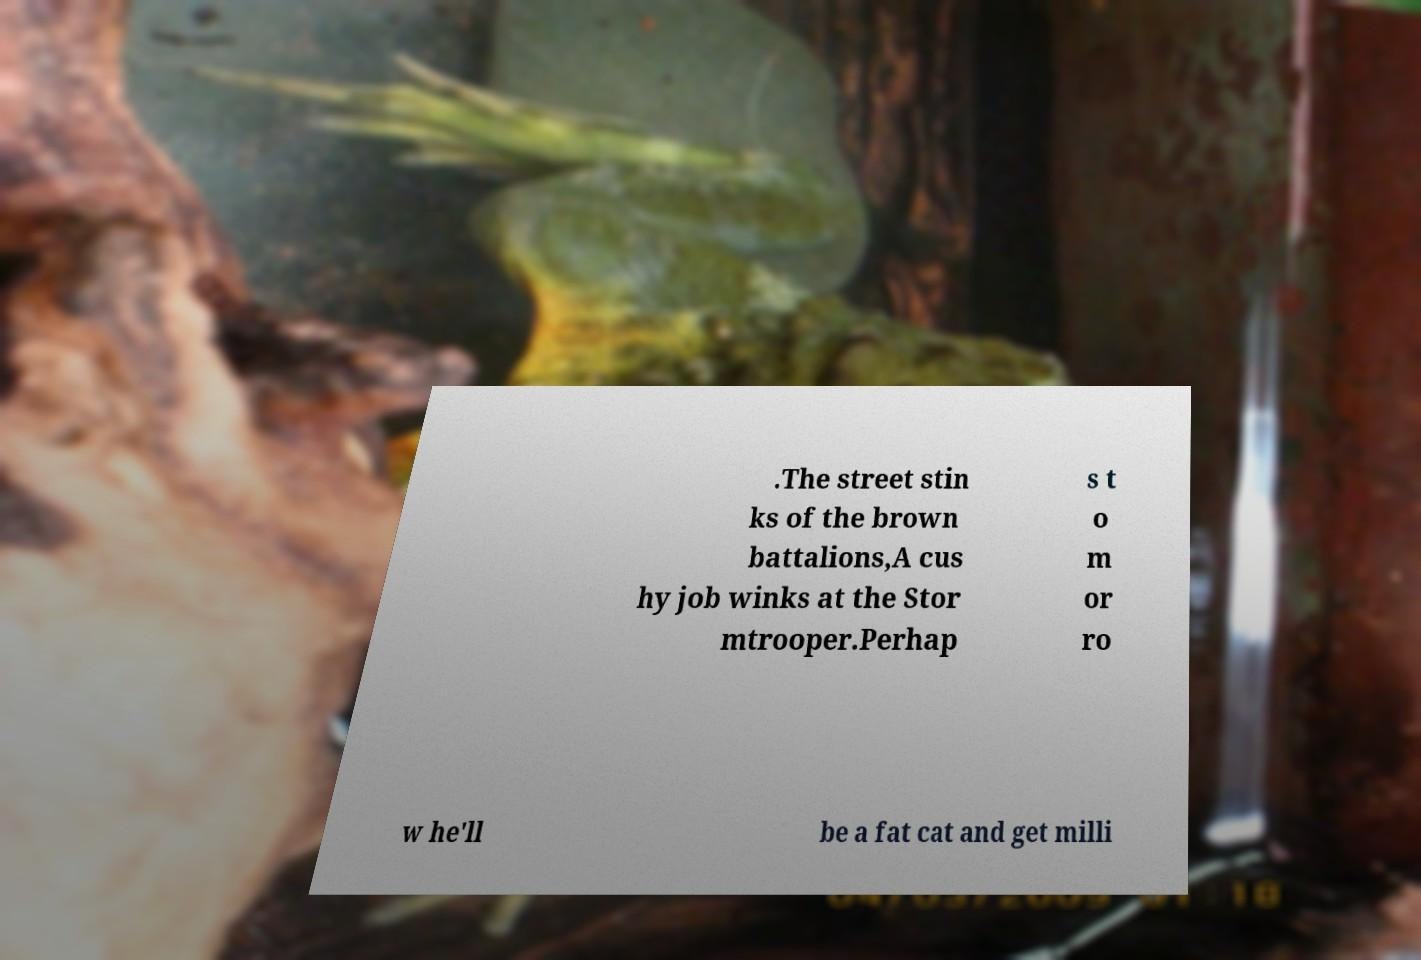I need the written content from this picture converted into text. Can you do that? .The street stin ks of the brown battalions,A cus hy job winks at the Stor mtrooper.Perhap s t o m or ro w he'll be a fat cat and get milli 